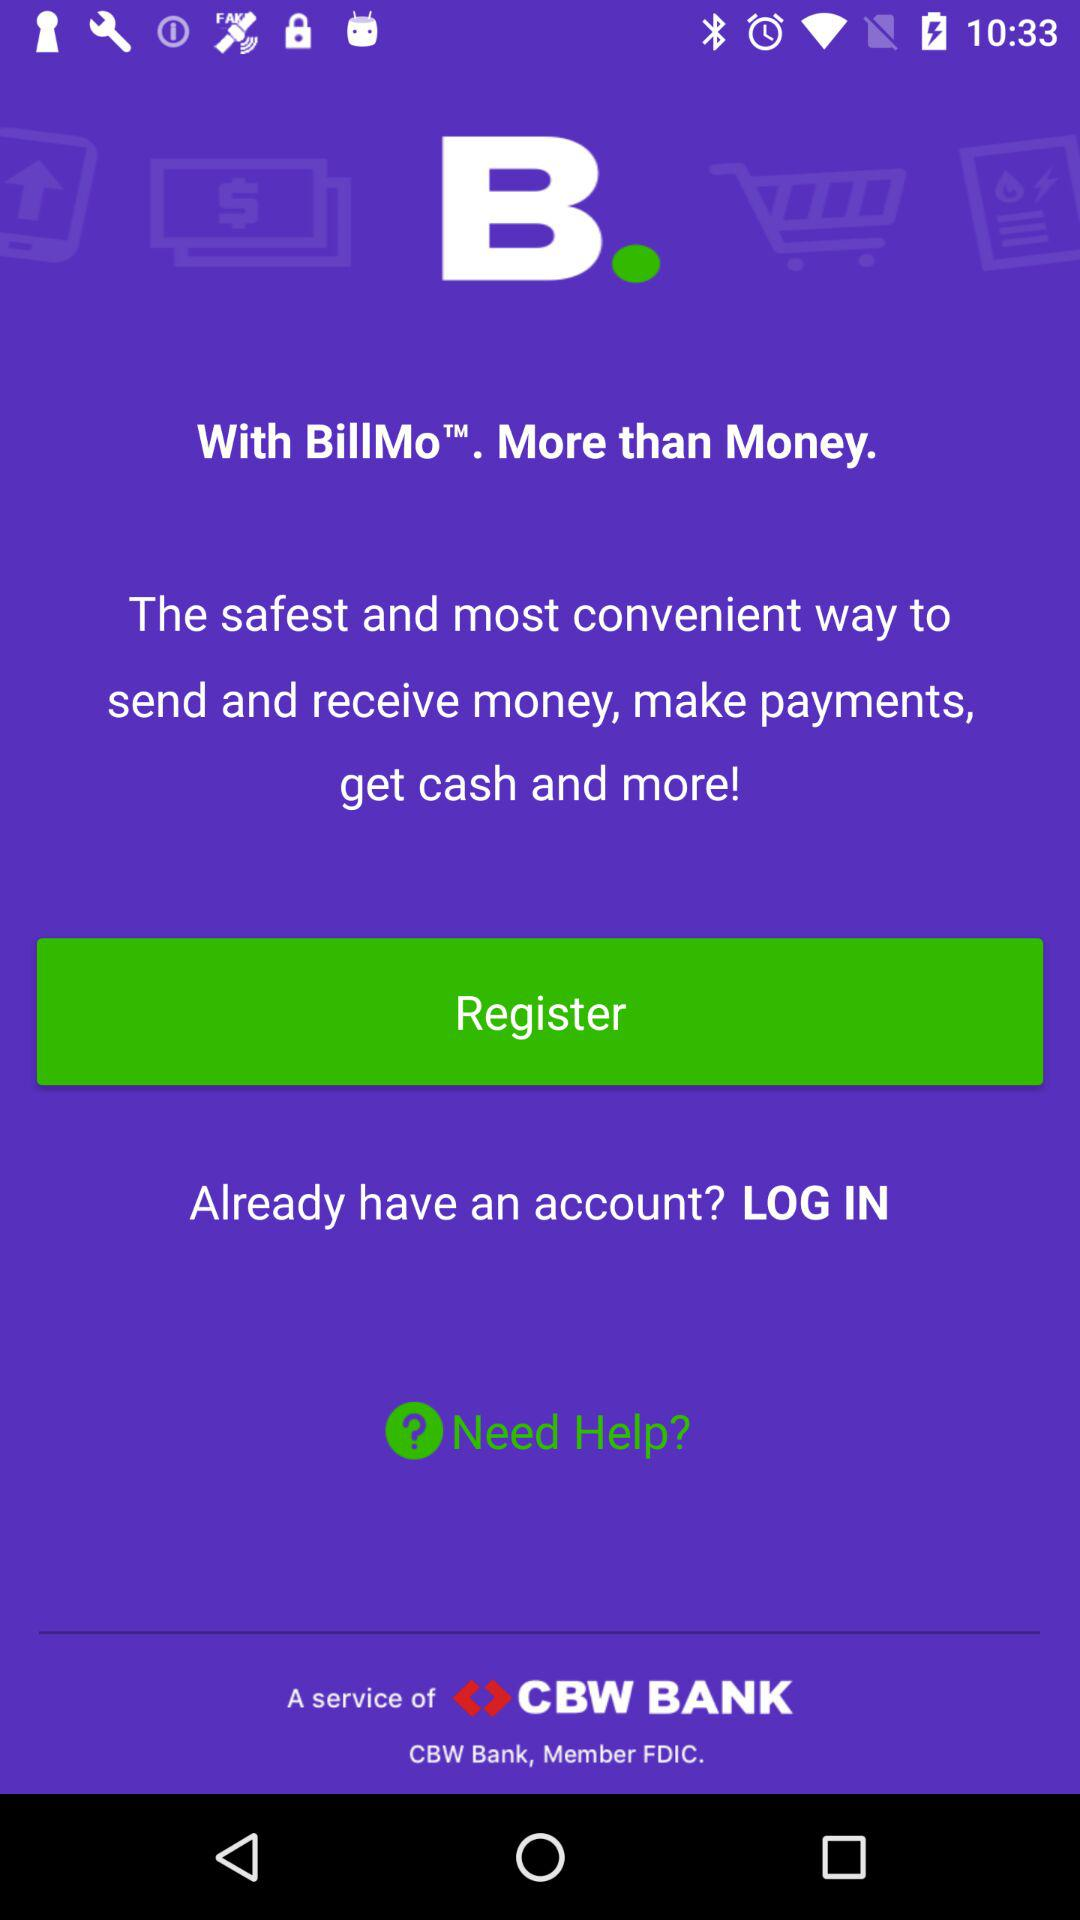What is the version of this application?
When the provided information is insufficient, respond with <no answer>. <no answer> 